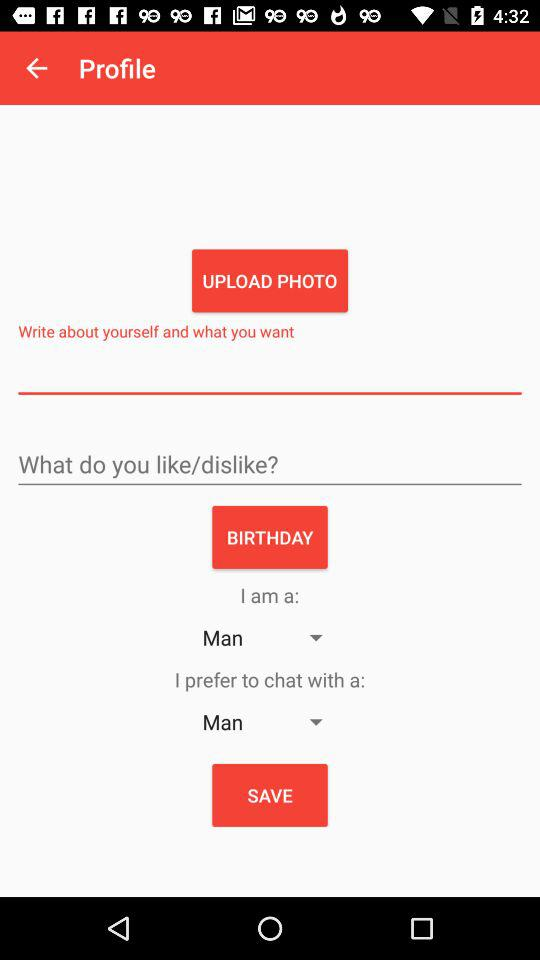Which date is selected as the birthday?
When the provided information is insufficient, respond with <no answer>. <no answer> 